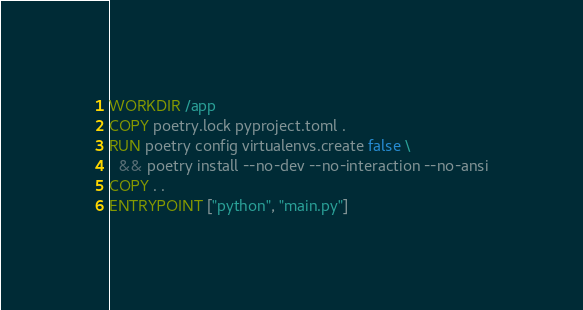Convert code to text. <code><loc_0><loc_0><loc_500><loc_500><_Dockerfile_>WORKDIR /app
COPY poetry.lock pyproject.toml .
RUN poetry config virtualenvs.create false \
  && poetry install --no-dev --no-interaction --no-ansi
COPY . .
ENTRYPOINT ["python", "main.py"]
</code> 